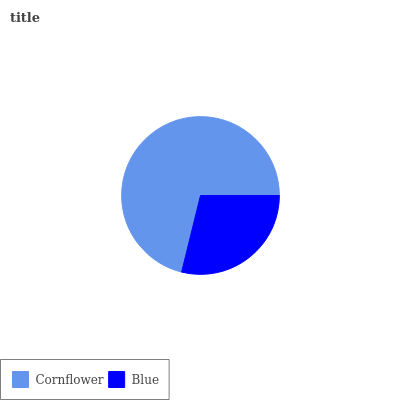Is Blue the minimum?
Answer yes or no. Yes. Is Cornflower the maximum?
Answer yes or no. Yes. Is Blue the maximum?
Answer yes or no. No. Is Cornflower greater than Blue?
Answer yes or no. Yes. Is Blue less than Cornflower?
Answer yes or no. Yes. Is Blue greater than Cornflower?
Answer yes or no. No. Is Cornflower less than Blue?
Answer yes or no. No. Is Cornflower the high median?
Answer yes or no. Yes. Is Blue the low median?
Answer yes or no. Yes. Is Blue the high median?
Answer yes or no. No. Is Cornflower the low median?
Answer yes or no. No. 